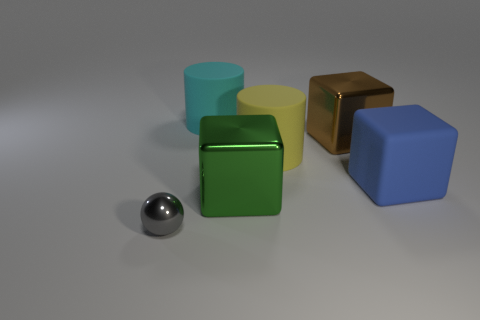How many objects are behind the green metallic block?
Give a very brief answer. 4. There is a big matte object on the right side of the big cylinder on the right side of the big cyan matte cylinder; what is its shape?
Your answer should be very brief. Cube. What is the shape of the big blue object that is made of the same material as the large cyan object?
Offer a terse response. Cube. There is a green block that is in front of the brown block; is its size the same as the metal thing that is behind the green metallic cube?
Provide a short and direct response. Yes. What is the shape of the metallic object behind the big blue rubber block?
Provide a short and direct response. Cube. The small sphere is what color?
Ensure brevity in your answer.  Gray. There is a cyan thing; is it the same size as the metal object that is in front of the big green metal cube?
Your answer should be compact. No. What number of matte things are either small gray balls or red objects?
Make the answer very short. 0. Is there anything else that has the same material as the brown block?
Keep it short and to the point. Yes. Does the ball have the same color as the large cylinder that is in front of the large cyan cylinder?
Your answer should be compact. No. 